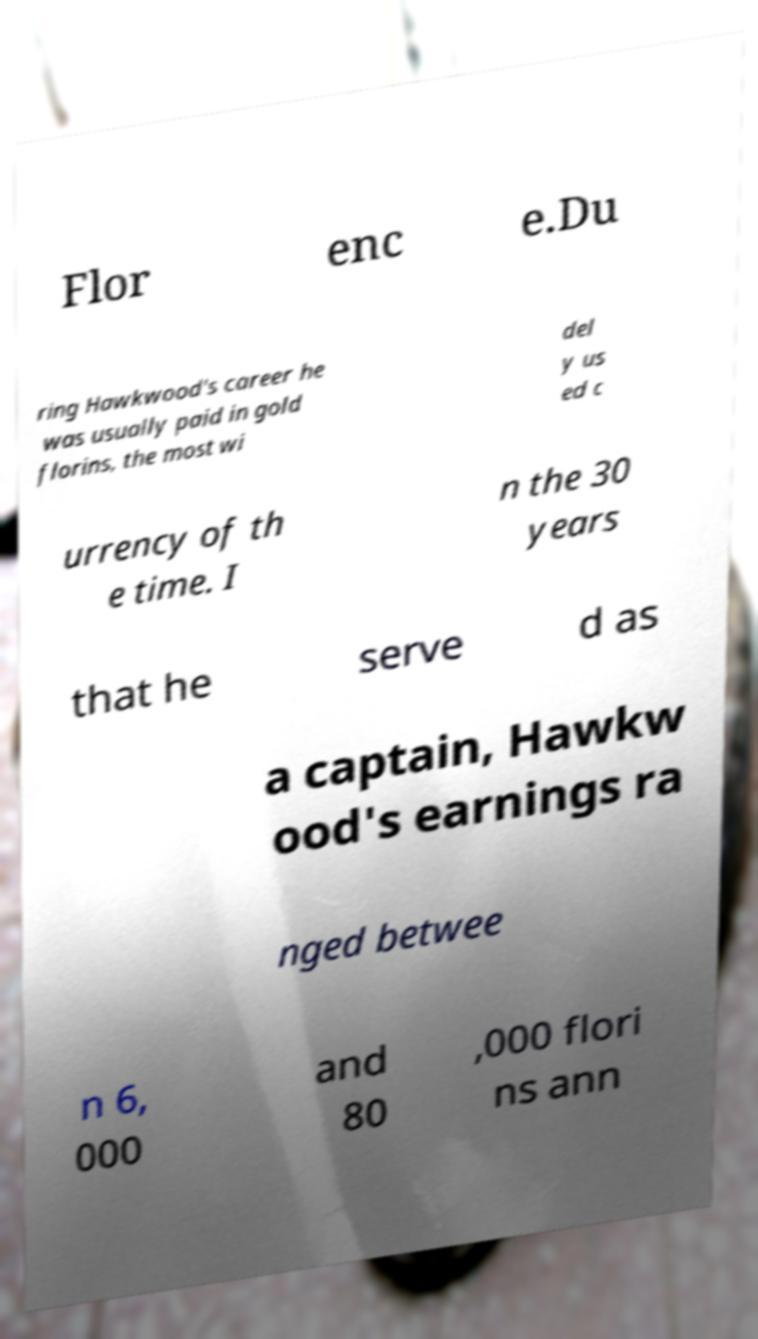Could you assist in decoding the text presented in this image and type it out clearly? Flor enc e.Du ring Hawkwood's career he was usually paid in gold florins, the most wi del y us ed c urrency of th e time. I n the 30 years that he serve d as a captain, Hawkw ood's earnings ra nged betwee n 6, 000 and 80 ,000 flori ns ann 